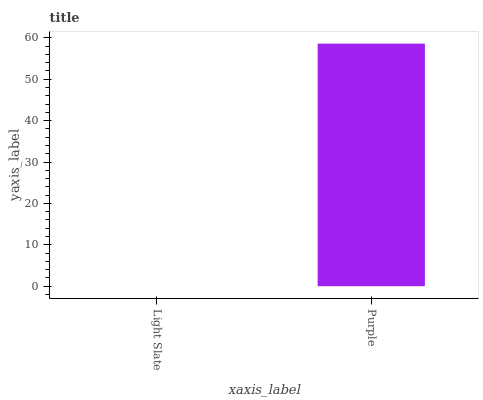Is Light Slate the minimum?
Answer yes or no. Yes. Is Purple the maximum?
Answer yes or no. Yes. Is Purple the minimum?
Answer yes or no. No. Is Purple greater than Light Slate?
Answer yes or no. Yes. Is Light Slate less than Purple?
Answer yes or no. Yes. Is Light Slate greater than Purple?
Answer yes or no. No. Is Purple less than Light Slate?
Answer yes or no. No. Is Purple the high median?
Answer yes or no. Yes. Is Light Slate the low median?
Answer yes or no. Yes. Is Light Slate the high median?
Answer yes or no. No. Is Purple the low median?
Answer yes or no. No. 